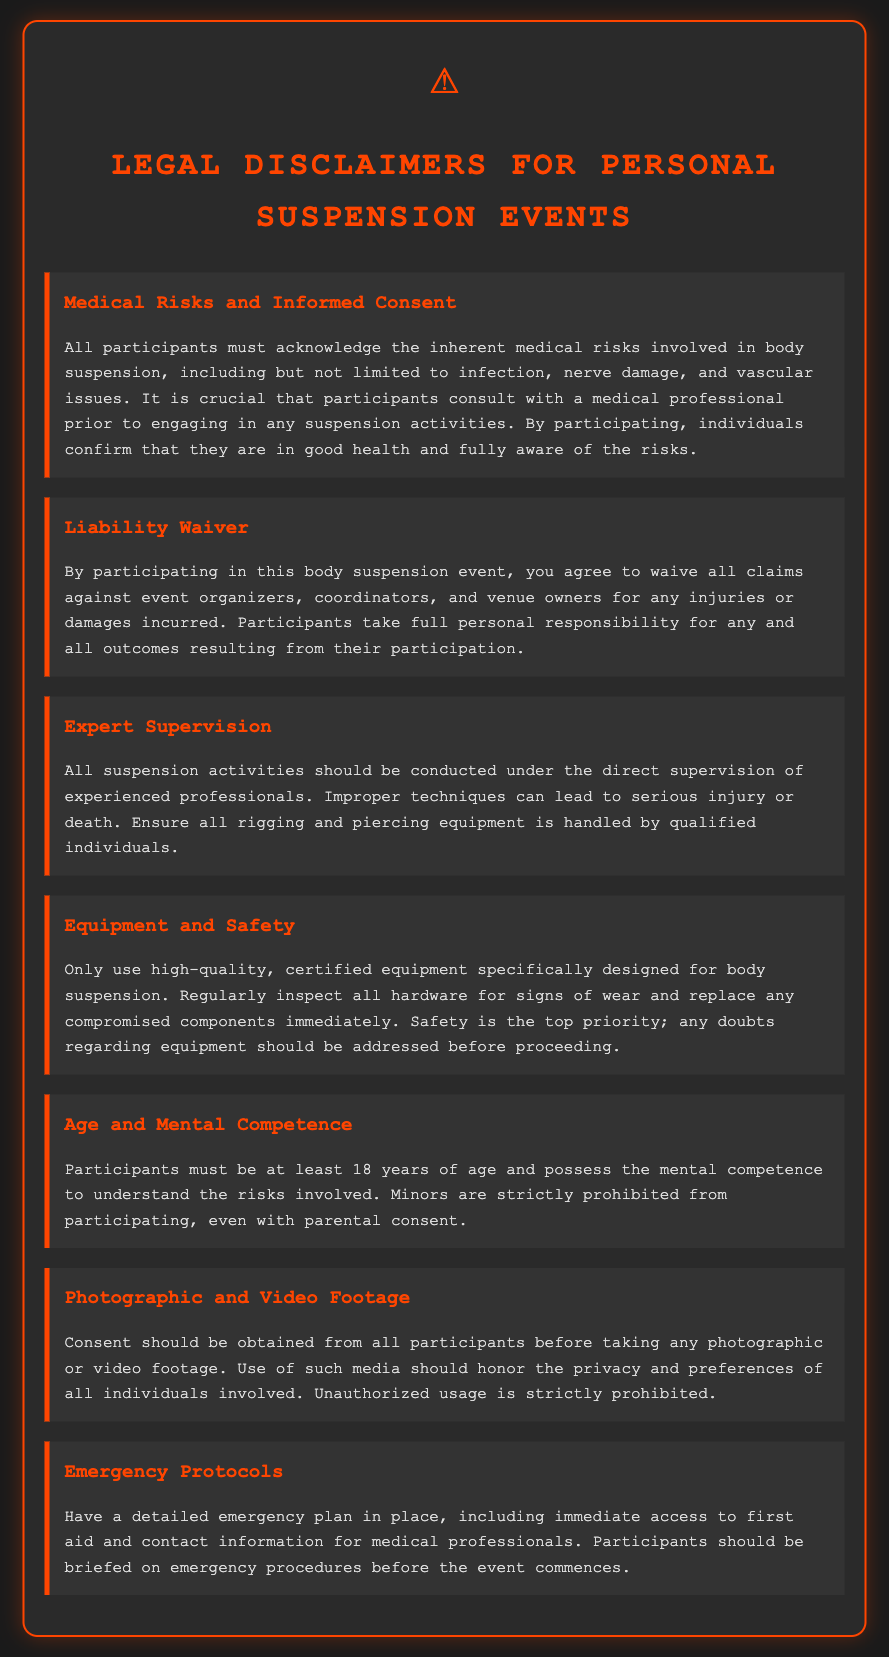What is the minimum age for participants? The document states that participants must be at least 18 years of age.
Answer: 18 years What must participants consult before engaging in suspension activities? The disclaimer emphasizes that participants must consult with a medical professional prior to participation.
Answer: medical professional What is crucial to ensure during suspension activities? The document highlights that suspension activities should be conducted under the direct supervision of experienced professionals.
Answer: supervision of experienced professionals What should participants do if they have doubts about equipment? The text indicates that any doubts regarding equipment should be addressed before proceeding.
Answer: addressed before proceeding What is strictly prohibited regarding minors? The warning states that minors are strictly prohibited from participating, even with parental consent.
Answer: strictly prohibited What type of equipment should be used for body suspension? The document specifies that only high-quality, certified equipment specifically designed for body suspension should be utilized.
Answer: high-quality, certified equipment What should be in place regarding emergency situations? The disclaimer mentions that a detailed emergency plan must be established, including immediate access to first aid.
Answer: emergency plan What consent is required before taking any footage? The document specifies that consent should be obtained from all participants before taking any photographic or video footage.
Answer: consent 